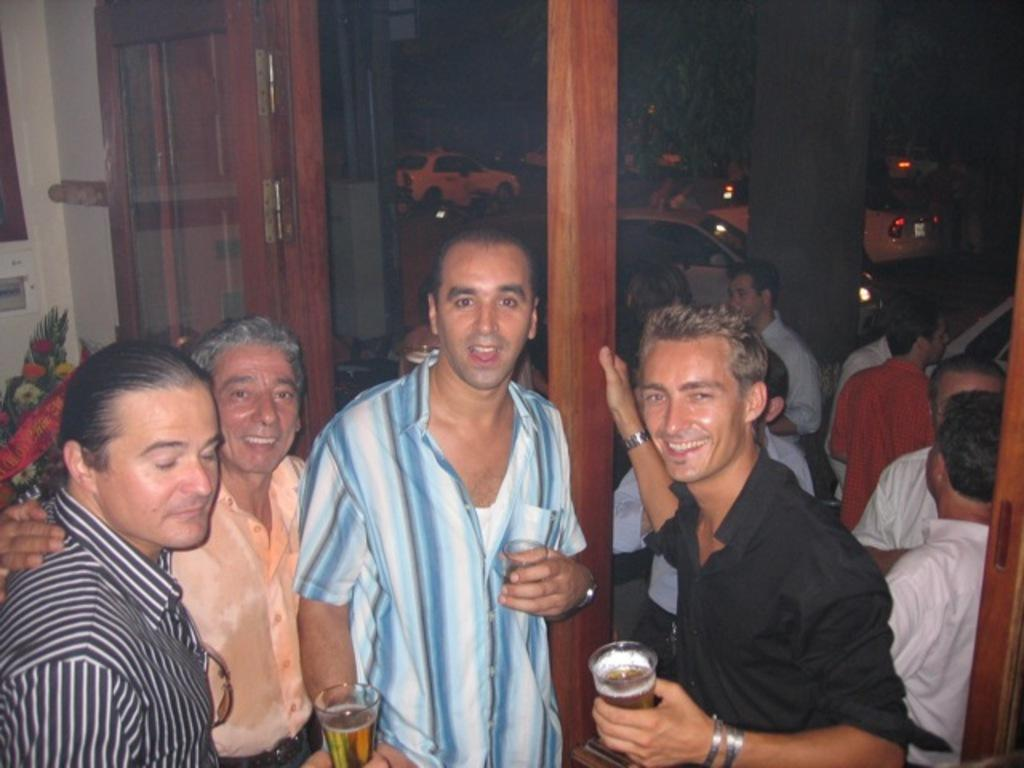How many people are in the image? There are many persons standing in the image. What is located on the left side of the image? There is a door and a bouquet on the left side of the image. Can you describe the background of the image? There are persons, cars, a pillar, and a tree visible in the background of the image. What type of scale can be seen in the image? There is no scale present in the image. How does the motion of the jail affect the persons in the image? There is no jail or motion present in the image. 